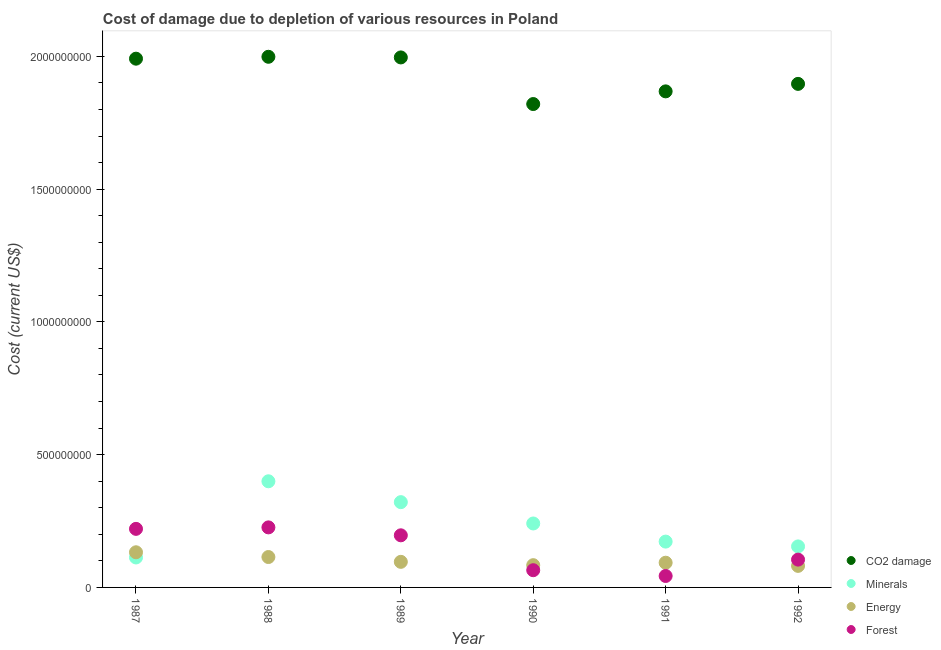Is the number of dotlines equal to the number of legend labels?
Ensure brevity in your answer.  Yes. What is the cost of damage due to depletion of energy in 1989?
Give a very brief answer. 9.63e+07. Across all years, what is the maximum cost of damage due to depletion of coal?
Your answer should be very brief. 2.00e+09. Across all years, what is the minimum cost of damage due to depletion of forests?
Offer a terse response. 4.31e+07. In which year was the cost of damage due to depletion of forests maximum?
Offer a very short reply. 1988. What is the total cost of damage due to depletion of coal in the graph?
Your answer should be very brief. 1.16e+1. What is the difference between the cost of damage due to depletion of energy in 1991 and that in 1992?
Make the answer very short. 1.19e+07. What is the difference between the cost of damage due to depletion of coal in 1987 and the cost of damage due to depletion of minerals in 1988?
Give a very brief answer. 1.59e+09. What is the average cost of damage due to depletion of energy per year?
Offer a terse response. 1.00e+08. In the year 1987, what is the difference between the cost of damage due to depletion of coal and cost of damage due to depletion of minerals?
Offer a terse response. 1.88e+09. What is the ratio of the cost of damage due to depletion of coal in 1988 to that in 1990?
Your response must be concise. 1.1. Is the cost of damage due to depletion of minerals in 1987 less than that in 1988?
Your answer should be compact. Yes. Is the difference between the cost of damage due to depletion of coal in 1987 and 1990 greater than the difference between the cost of damage due to depletion of minerals in 1987 and 1990?
Offer a terse response. Yes. What is the difference between the highest and the second highest cost of damage due to depletion of coal?
Give a very brief answer. 2.41e+06. What is the difference between the highest and the lowest cost of damage due to depletion of coal?
Offer a very short reply. 1.78e+08. Is the sum of the cost of damage due to depletion of forests in 1987 and 1990 greater than the maximum cost of damage due to depletion of coal across all years?
Ensure brevity in your answer.  No. Is it the case that in every year, the sum of the cost of damage due to depletion of coal and cost of damage due to depletion of minerals is greater than the cost of damage due to depletion of energy?
Offer a very short reply. Yes. Does the cost of damage due to depletion of minerals monotonically increase over the years?
Your answer should be compact. No. Is the cost of damage due to depletion of energy strictly less than the cost of damage due to depletion of forests over the years?
Provide a short and direct response. No. How many dotlines are there?
Your answer should be compact. 4. How many years are there in the graph?
Provide a succinct answer. 6. Does the graph contain any zero values?
Ensure brevity in your answer.  No. Where does the legend appear in the graph?
Your response must be concise. Bottom right. How many legend labels are there?
Your response must be concise. 4. What is the title of the graph?
Your answer should be very brief. Cost of damage due to depletion of various resources in Poland . Does "Public sector management" appear as one of the legend labels in the graph?
Your response must be concise. No. What is the label or title of the X-axis?
Make the answer very short. Year. What is the label or title of the Y-axis?
Offer a very short reply. Cost (current US$). What is the Cost (current US$) in CO2 damage in 1987?
Ensure brevity in your answer.  1.99e+09. What is the Cost (current US$) of Minerals in 1987?
Ensure brevity in your answer.  1.13e+08. What is the Cost (current US$) of Energy in 1987?
Provide a short and direct response. 1.32e+08. What is the Cost (current US$) in Forest in 1987?
Offer a very short reply. 2.21e+08. What is the Cost (current US$) of CO2 damage in 1988?
Offer a very short reply. 2.00e+09. What is the Cost (current US$) in Minerals in 1988?
Make the answer very short. 4.00e+08. What is the Cost (current US$) in Energy in 1988?
Keep it short and to the point. 1.14e+08. What is the Cost (current US$) of Forest in 1988?
Provide a succinct answer. 2.26e+08. What is the Cost (current US$) in CO2 damage in 1989?
Offer a very short reply. 2.00e+09. What is the Cost (current US$) of Minerals in 1989?
Your answer should be compact. 3.21e+08. What is the Cost (current US$) of Energy in 1989?
Provide a short and direct response. 9.63e+07. What is the Cost (current US$) in Forest in 1989?
Ensure brevity in your answer.  1.96e+08. What is the Cost (current US$) of CO2 damage in 1990?
Make the answer very short. 1.82e+09. What is the Cost (current US$) of Minerals in 1990?
Offer a very short reply. 2.41e+08. What is the Cost (current US$) of Energy in 1990?
Your response must be concise. 8.38e+07. What is the Cost (current US$) in Forest in 1990?
Offer a very short reply. 6.49e+07. What is the Cost (current US$) in CO2 damage in 1991?
Provide a short and direct response. 1.87e+09. What is the Cost (current US$) of Minerals in 1991?
Ensure brevity in your answer.  1.73e+08. What is the Cost (current US$) in Energy in 1991?
Provide a succinct answer. 9.31e+07. What is the Cost (current US$) in Forest in 1991?
Your answer should be compact. 4.31e+07. What is the Cost (current US$) in CO2 damage in 1992?
Your response must be concise. 1.90e+09. What is the Cost (current US$) of Minerals in 1992?
Offer a terse response. 1.54e+08. What is the Cost (current US$) of Energy in 1992?
Make the answer very short. 8.11e+07. What is the Cost (current US$) of Forest in 1992?
Provide a succinct answer. 1.05e+08. Across all years, what is the maximum Cost (current US$) of CO2 damage?
Ensure brevity in your answer.  2.00e+09. Across all years, what is the maximum Cost (current US$) of Minerals?
Your answer should be compact. 4.00e+08. Across all years, what is the maximum Cost (current US$) in Energy?
Provide a short and direct response. 1.32e+08. Across all years, what is the maximum Cost (current US$) in Forest?
Offer a very short reply. 2.26e+08. Across all years, what is the minimum Cost (current US$) in CO2 damage?
Offer a terse response. 1.82e+09. Across all years, what is the minimum Cost (current US$) of Minerals?
Keep it short and to the point. 1.13e+08. Across all years, what is the minimum Cost (current US$) of Energy?
Keep it short and to the point. 8.11e+07. Across all years, what is the minimum Cost (current US$) of Forest?
Give a very brief answer. 4.31e+07. What is the total Cost (current US$) in CO2 damage in the graph?
Your answer should be compact. 1.16e+1. What is the total Cost (current US$) in Minerals in the graph?
Make the answer very short. 1.40e+09. What is the total Cost (current US$) of Energy in the graph?
Offer a very short reply. 6.01e+08. What is the total Cost (current US$) of Forest in the graph?
Ensure brevity in your answer.  8.56e+08. What is the difference between the Cost (current US$) of CO2 damage in 1987 and that in 1988?
Provide a succinct answer. -7.11e+06. What is the difference between the Cost (current US$) of Minerals in 1987 and that in 1988?
Offer a very short reply. -2.87e+08. What is the difference between the Cost (current US$) of Energy in 1987 and that in 1988?
Your answer should be very brief. 1.79e+07. What is the difference between the Cost (current US$) of Forest in 1987 and that in 1988?
Give a very brief answer. -5.56e+06. What is the difference between the Cost (current US$) in CO2 damage in 1987 and that in 1989?
Your answer should be compact. -4.69e+06. What is the difference between the Cost (current US$) of Minerals in 1987 and that in 1989?
Keep it short and to the point. -2.08e+08. What is the difference between the Cost (current US$) of Energy in 1987 and that in 1989?
Ensure brevity in your answer.  3.60e+07. What is the difference between the Cost (current US$) of Forest in 1987 and that in 1989?
Provide a short and direct response. 2.43e+07. What is the difference between the Cost (current US$) of CO2 damage in 1987 and that in 1990?
Keep it short and to the point. 1.71e+08. What is the difference between the Cost (current US$) of Minerals in 1987 and that in 1990?
Your answer should be compact. -1.28e+08. What is the difference between the Cost (current US$) of Energy in 1987 and that in 1990?
Provide a succinct answer. 4.86e+07. What is the difference between the Cost (current US$) of Forest in 1987 and that in 1990?
Ensure brevity in your answer.  1.56e+08. What is the difference between the Cost (current US$) of CO2 damage in 1987 and that in 1991?
Keep it short and to the point. 1.23e+08. What is the difference between the Cost (current US$) in Minerals in 1987 and that in 1991?
Ensure brevity in your answer.  -5.97e+07. What is the difference between the Cost (current US$) in Energy in 1987 and that in 1991?
Your answer should be very brief. 3.93e+07. What is the difference between the Cost (current US$) of Forest in 1987 and that in 1991?
Give a very brief answer. 1.77e+08. What is the difference between the Cost (current US$) of CO2 damage in 1987 and that in 1992?
Give a very brief answer. 9.49e+07. What is the difference between the Cost (current US$) in Minerals in 1987 and that in 1992?
Make the answer very short. -4.16e+07. What is the difference between the Cost (current US$) in Energy in 1987 and that in 1992?
Your answer should be very brief. 5.13e+07. What is the difference between the Cost (current US$) in Forest in 1987 and that in 1992?
Your answer should be compact. 1.16e+08. What is the difference between the Cost (current US$) of CO2 damage in 1988 and that in 1989?
Offer a very short reply. 2.41e+06. What is the difference between the Cost (current US$) in Minerals in 1988 and that in 1989?
Provide a short and direct response. 7.86e+07. What is the difference between the Cost (current US$) in Energy in 1988 and that in 1989?
Your response must be concise. 1.81e+07. What is the difference between the Cost (current US$) in Forest in 1988 and that in 1989?
Ensure brevity in your answer.  2.99e+07. What is the difference between the Cost (current US$) of CO2 damage in 1988 and that in 1990?
Provide a short and direct response. 1.78e+08. What is the difference between the Cost (current US$) of Minerals in 1988 and that in 1990?
Offer a terse response. 1.59e+08. What is the difference between the Cost (current US$) of Energy in 1988 and that in 1990?
Provide a short and direct response. 3.07e+07. What is the difference between the Cost (current US$) in Forest in 1988 and that in 1990?
Make the answer very short. 1.61e+08. What is the difference between the Cost (current US$) in CO2 damage in 1988 and that in 1991?
Provide a succinct answer. 1.30e+08. What is the difference between the Cost (current US$) of Minerals in 1988 and that in 1991?
Your answer should be very brief. 2.27e+08. What is the difference between the Cost (current US$) in Energy in 1988 and that in 1991?
Provide a succinct answer. 2.14e+07. What is the difference between the Cost (current US$) in Forest in 1988 and that in 1991?
Provide a succinct answer. 1.83e+08. What is the difference between the Cost (current US$) of CO2 damage in 1988 and that in 1992?
Keep it short and to the point. 1.02e+08. What is the difference between the Cost (current US$) of Minerals in 1988 and that in 1992?
Make the answer very short. 2.45e+08. What is the difference between the Cost (current US$) of Energy in 1988 and that in 1992?
Keep it short and to the point. 3.34e+07. What is the difference between the Cost (current US$) in Forest in 1988 and that in 1992?
Your response must be concise. 1.21e+08. What is the difference between the Cost (current US$) in CO2 damage in 1989 and that in 1990?
Your answer should be very brief. 1.76e+08. What is the difference between the Cost (current US$) of Minerals in 1989 and that in 1990?
Ensure brevity in your answer.  8.03e+07. What is the difference between the Cost (current US$) in Energy in 1989 and that in 1990?
Give a very brief answer. 1.26e+07. What is the difference between the Cost (current US$) of Forest in 1989 and that in 1990?
Provide a succinct answer. 1.31e+08. What is the difference between the Cost (current US$) of CO2 damage in 1989 and that in 1991?
Your answer should be very brief. 1.28e+08. What is the difference between the Cost (current US$) of Minerals in 1989 and that in 1991?
Keep it short and to the point. 1.49e+08. What is the difference between the Cost (current US$) of Energy in 1989 and that in 1991?
Give a very brief answer. 3.30e+06. What is the difference between the Cost (current US$) in Forest in 1989 and that in 1991?
Keep it short and to the point. 1.53e+08. What is the difference between the Cost (current US$) in CO2 damage in 1989 and that in 1992?
Your answer should be compact. 9.96e+07. What is the difference between the Cost (current US$) of Minerals in 1989 and that in 1992?
Your answer should be compact. 1.67e+08. What is the difference between the Cost (current US$) of Energy in 1989 and that in 1992?
Provide a succinct answer. 1.52e+07. What is the difference between the Cost (current US$) of Forest in 1989 and that in 1992?
Give a very brief answer. 9.15e+07. What is the difference between the Cost (current US$) in CO2 damage in 1990 and that in 1991?
Your response must be concise. -4.77e+07. What is the difference between the Cost (current US$) of Minerals in 1990 and that in 1991?
Your answer should be very brief. 6.83e+07. What is the difference between the Cost (current US$) in Energy in 1990 and that in 1991?
Provide a short and direct response. -9.26e+06. What is the difference between the Cost (current US$) in Forest in 1990 and that in 1991?
Offer a terse response. 2.17e+07. What is the difference between the Cost (current US$) in CO2 damage in 1990 and that in 1992?
Offer a terse response. -7.59e+07. What is the difference between the Cost (current US$) of Minerals in 1990 and that in 1992?
Offer a terse response. 8.64e+07. What is the difference between the Cost (current US$) of Energy in 1990 and that in 1992?
Make the answer very short. 2.67e+06. What is the difference between the Cost (current US$) of Forest in 1990 and that in 1992?
Your answer should be compact. -3.99e+07. What is the difference between the Cost (current US$) of CO2 damage in 1991 and that in 1992?
Make the answer very short. -2.82e+07. What is the difference between the Cost (current US$) of Minerals in 1991 and that in 1992?
Provide a short and direct response. 1.81e+07. What is the difference between the Cost (current US$) of Energy in 1991 and that in 1992?
Keep it short and to the point. 1.19e+07. What is the difference between the Cost (current US$) in Forest in 1991 and that in 1992?
Your response must be concise. -6.16e+07. What is the difference between the Cost (current US$) in CO2 damage in 1987 and the Cost (current US$) in Minerals in 1988?
Your response must be concise. 1.59e+09. What is the difference between the Cost (current US$) in CO2 damage in 1987 and the Cost (current US$) in Energy in 1988?
Give a very brief answer. 1.88e+09. What is the difference between the Cost (current US$) of CO2 damage in 1987 and the Cost (current US$) of Forest in 1988?
Provide a succinct answer. 1.77e+09. What is the difference between the Cost (current US$) of Minerals in 1987 and the Cost (current US$) of Energy in 1988?
Your response must be concise. -1.66e+06. What is the difference between the Cost (current US$) in Minerals in 1987 and the Cost (current US$) in Forest in 1988?
Make the answer very short. -1.13e+08. What is the difference between the Cost (current US$) of Energy in 1987 and the Cost (current US$) of Forest in 1988?
Your response must be concise. -9.37e+07. What is the difference between the Cost (current US$) in CO2 damage in 1987 and the Cost (current US$) in Minerals in 1989?
Offer a very short reply. 1.67e+09. What is the difference between the Cost (current US$) in CO2 damage in 1987 and the Cost (current US$) in Energy in 1989?
Your response must be concise. 1.89e+09. What is the difference between the Cost (current US$) of CO2 damage in 1987 and the Cost (current US$) of Forest in 1989?
Provide a short and direct response. 1.80e+09. What is the difference between the Cost (current US$) of Minerals in 1987 and the Cost (current US$) of Energy in 1989?
Your answer should be compact. 1.65e+07. What is the difference between the Cost (current US$) in Minerals in 1987 and the Cost (current US$) in Forest in 1989?
Give a very brief answer. -8.34e+07. What is the difference between the Cost (current US$) of Energy in 1987 and the Cost (current US$) of Forest in 1989?
Your answer should be compact. -6.39e+07. What is the difference between the Cost (current US$) of CO2 damage in 1987 and the Cost (current US$) of Minerals in 1990?
Keep it short and to the point. 1.75e+09. What is the difference between the Cost (current US$) of CO2 damage in 1987 and the Cost (current US$) of Energy in 1990?
Provide a short and direct response. 1.91e+09. What is the difference between the Cost (current US$) in CO2 damage in 1987 and the Cost (current US$) in Forest in 1990?
Ensure brevity in your answer.  1.93e+09. What is the difference between the Cost (current US$) in Minerals in 1987 and the Cost (current US$) in Energy in 1990?
Provide a succinct answer. 2.90e+07. What is the difference between the Cost (current US$) of Minerals in 1987 and the Cost (current US$) of Forest in 1990?
Provide a succinct answer. 4.80e+07. What is the difference between the Cost (current US$) in Energy in 1987 and the Cost (current US$) in Forest in 1990?
Your response must be concise. 6.75e+07. What is the difference between the Cost (current US$) in CO2 damage in 1987 and the Cost (current US$) in Minerals in 1991?
Provide a succinct answer. 1.82e+09. What is the difference between the Cost (current US$) in CO2 damage in 1987 and the Cost (current US$) in Energy in 1991?
Provide a short and direct response. 1.90e+09. What is the difference between the Cost (current US$) of CO2 damage in 1987 and the Cost (current US$) of Forest in 1991?
Make the answer very short. 1.95e+09. What is the difference between the Cost (current US$) in Minerals in 1987 and the Cost (current US$) in Energy in 1991?
Provide a short and direct response. 1.98e+07. What is the difference between the Cost (current US$) in Minerals in 1987 and the Cost (current US$) in Forest in 1991?
Keep it short and to the point. 6.97e+07. What is the difference between the Cost (current US$) in Energy in 1987 and the Cost (current US$) in Forest in 1991?
Keep it short and to the point. 8.93e+07. What is the difference between the Cost (current US$) of CO2 damage in 1987 and the Cost (current US$) of Minerals in 1992?
Keep it short and to the point. 1.84e+09. What is the difference between the Cost (current US$) of CO2 damage in 1987 and the Cost (current US$) of Energy in 1992?
Give a very brief answer. 1.91e+09. What is the difference between the Cost (current US$) in CO2 damage in 1987 and the Cost (current US$) in Forest in 1992?
Give a very brief answer. 1.89e+09. What is the difference between the Cost (current US$) of Minerals in 1987 and the Cost (current US$) of Energy in 1992?
Your answer should be compact. 3.17e+07. What is the difference between the Cost (current US$) in Minerals in 1987 and the Cost (current US$) in Forest in 1992?
Your answer should be very brief. 8.09e+06. What is the difference between the Cost (current US$) of Energy in 1987 and the Cost (current US$) of Forest in 1992?
Provide a short and direct response. 2.76e+07. What is the difference between the Cost (current US$) in CO2 damage in 1988 and the Cost (current US$) in Minerals in 1989?
Give a very brief answer. 1.68e+09. What is the difference between the Cost (current US$) in CO2 damage in 1988 and the Cost (current US$) in Energy in 1989?
Ensure brevity in your answer.  1.90e+09. What is the difference between the Cost (current US$) of CO2 damage in 1988 and the Cost (current US$) of Forest in 1989?
Keep it short and to the point. 1.80e+09. What is the difference between the Cost (current US$) in Minerals in 1988 and the Cost (current US$) in Energy in 1989?
Your response must be concise. 3.03e+08. What is the difference between the Cost (current US$) in Minerals in 1988 and the Cost (current US$) in Forest in 1989?
Your answer should be compact. 2.03e+08. What is the difference between the Cost (current US$) in Energy in 1988 and the Cost (current US$) in Forest in 1989?
Provide a succinct answer. -8.18e+07. What is the difference between the Cost (current US$) of CO2 damage in 1988 and the Cost (current US$) of Minerals in 1990?
Provide a succinct answer. 1.76e+09. What is the difference between the Cost (current US$) in CO2 damage in 1988 and the Cost (current US$) in Energy in 1990?
Provide a succinct answer. 1.91e+09. What is the difference between the Cost (current US$) in CO2 damage in 1988 and the Cost (current US$) in Forest in 1990?
Your answer should be very brief. 1.93e+09. What is the difference between the Cost (current US$) of Minerals in 1988 and the Cost (current US$) of Energy in 1990?
Ensure brevity in your answer.  3.16e+08. What is the difference between the Cost (current US$) of Minerals in 1988 and the Cost (current US$) of Forest in 1990?
Your answer should be very brief. 3.35e+08. What is the difference between the Cost (current US$) of Energy in 1988 and the Cost (current US$) of Forest in 1990?
Give a very brief answer. 4.96e+07. What is the difference between the Cost (current US$) of CO2 damage in 1988 and the Cost (current US$) of Minerals in 1991?
Ensure brevity in your answer.  1.83e+09. What is the difference between the Cost (current US$) of CO2 damage in 1988 and the Cost (current US$) of Energy in 1991?
Give a very brief answer. 1.91e+09. What is the difference between the Cost (current US$) of CO2 damage in 1988 and the Cost (current US$) of Forest in 1991?
Offer a terse response. 1.96e+09. What is the difference between the Cost (current US$) in Minerals in 1988 and the Cost (current US$) in Energy in 1991?
Your answer should be compact. 3.07e+08. What is the difference between the Cost (current US$) of Minerals in 1988 and the Cost (current US$) of Forest in 1991?
Make the answer very short. 3.57e+08. What is the difference between the Cost (current US$) of Energy in 1988 and the Cost (current US$) of Forest in 1991?
Provide a short and direct response. 7.14e+07. What is the difference between the Cost (current US$) in CO2 damage in 1988 and the Cost (current US$) in Minerals in 1992?
Keep it short and to the point. 1.84e+09. What is the difference between the Cost (current US$) in CO2 damage in 1988 and the Cost (current US$) in Energy in 1992?
Provide a succinct answer. 1.92e+09. What is the difference between the Cost (current US$) of CO2 damage in 1988 and the Cost (current US$) of Forest in 1992?
Your answer should be compact. 1.89e+09. What is the difference between the Cost (current US$) of Minerals in 1988 and the Cost (current US$) of Energy in 1992?
Keep it short and to the point. 3.19e+08. What is the difference between the Cost (current US$) in Minerals in 1988 and the Cost (current US$) in Forest in 1992?
Keep it short and to the point. 2.95e+08. What is the difference between the Cost (current US$) of Energy in 1988 and the Cost (current US$) of Forest in 1992?
Your answer should be very brief. 9.74e+06. What is the difference between the Cost (current US$) in CO2 damage in 1989 and the Cost (current US$) in Minerals in 1990?
Offer a terse response. 1.76e+09. What is the difference between the Cost (current US$) of CO2 damage in 1989 and the Cost (current US$) of Energy in 1990?
Provide a succinct answer. 1.91e+09. What is the difference between the Cost (current US$) of CO2 damage in 1989 and the Cost (current US$) of Forest in 1990?
Keep it short and to the point. 1.93e+09. What is the difference between the Cost (current US$) of Minerals in 1989 and the Cost (current US$) of Energy in 1990?
Make the answer very short. 2.37e+08. What is the difference between the Cost (current US$) in Minerals in 1989 and the Cost (current US$) in Forest in 1990?
Provide a short and direct response. 2.56e+08. What is the difference between the Cost (current US$) of Energy in 1989 and the Cost (current US$) of Forest in 1990?
Ensure brevity in your answer.  3.15e+07. What is the difference between the Cost (current US$) of CO2 damage in 1989 and the Cost (current US$) of Minerals in 1991?
Offer a very short reply. 1.82e+09. What is the difference between the Cost (current US$) in CO2 damage in 1989 and the Cost (current US$) in Energy in 1991?
Give a very brief answer. 1.90e+09. What is the difference between the Cost (current US$) of CO2 damage in 1989 and the Cost (current US$) of Forest in 1991?
Offer a terse response. 1.95e+09. What is the difference between the Cost (current US$) in Minerals in 1989 and the Cost (current US$) in Energy in 1991?
Your response must be concise. 2.28e+08. What is the difference between the Cost (current US$) in Minerals in 1989 and the Cost (current US$) in Forest in 1991?
Keep it short and to the point. 2.78e+08. What is the difference between the Cost (current US$) of Energy in 1989 and the Cost (current US$) of Forest in 1991?
Provide a short and direct response. 5.32e+07. What is the difference between the Cost (current US$) in CO2 damage in 1989 and the Cost (current US$) in Minerals in 1992?
Your response must be concise. 1.84e+09. What is the difference between the Cost (current US$) in CO2 damage in 1989 and the Cost (current US$) in Energy in 1992?
Provide a short and direct response. 1.91e+09. What is the difference between the Cost (current US$) of CO2 damage in 1989 and the Cost (current US$) of Forest in 1992?
Offer a very short reply. 1.89e+09. What is the difference between the Cost (current US$) of Minerals in 1989 and the Cost (current US$) of Energy in 1992?
Keep it short and to the point. 2.40e+08. What is the difference between the Cost (current US$) of Minerals in 1989 and the Cost (current US$) of Forest in 1992?
Your response must be concise. 2.16e+08. What is the difference between the Cost (current US$) in Energy in 1989 and the Cost (current US$) in Forest in 1992?
Your response must be concise. -8.39e+06. What is the difference between the Cost (current US$) of CO2 damage in 1990 and the Cost (current US$) of Minerals in 1991?
Provide a succinct answer. 1.65e+09. What is the difference between the Cost (current US$) in CO2 damage in 1990 and the Cost (current US$) in Energy in 1991?
Your answer should be compact. 1.73e+09. What is the difference between the Cost (current US$) in CO2 damage in 1990 and the Cost (current US$) in Forest in 1991?
Your answer should be very brief. 1.78e+09. What is the difference between the Cost (current US$) in Minerals in 1990 and the Cost (current US$) in Energy in 1991?
Offer a very short reply. 1.48e+08. What is the difference between the Cost (current US$) of Minerals in 1990 and the Cost (current US$) of Forest in 1991?
Offer a terse response. 1.98e+08. What is the difference between the Cost (current US$) of Energy in 1990 and the Cost (current US$) of Forest in 1991?
Keep it short and to the point. 4.07e+07. What is the difference between the Cost (current US$) of CO2 damage in 1990 and the Cost (current US$) of Minerals in 1992?
Give a very brief answer. 1.67e+09. What is the difference between the Cost (current US$) of CO2 damage in 1990 and the Cost (current US$) of Energy in 1992?
Give a very brief answer. 1.74e+09. What is the difference between the Cost (current US$) of CO2 damage in 1990 and the Cost (current US$) of Forest in 1992?
Offer a very short reply. 1.72e+09. What is the difference between the Cost (current US$) in Minerals in 1990 and the Cost (current US$) in Energy in 1992?
Provide a succinct answer. 1.60e+08. What is the difference between the Cost (current US$) in Minerals in 1990 and the Cost (current US$) in Forest in 1992?
Ensure brevity in your answer.  1.36e+08. What is the difference between the Cost (current US$) in Energy in 1990 and the Cost (current US$) in Forest in 1992?
Your answer should be very brief. -2.09e+07. What is the difference between the Cost (current US$) in CO2 damage in 1991 and the Cost (current US$) in Minerals in 1992?
Provide a short and direct response. 1.71e+09. What is the difference between the Cost (current US$) of CO2 damage in 1991 and the Cost (current US$) of Energy in 1992?
Your response must be concise. 1.79e+09. What is the difference between the Cost (current US$) in CO2 damage in 1991 and the Cost (current US$) in Forest in 1992?
Ensure brevity in your answer.  1.76e+09. What is the difference between the Cost (current US$) in Minerals in 1991 and the Cost (current US$) in Energy in 1992?
Provide a succinct answer. 9.14e+07. What is the difference between the Cost (current US$) in Minerals in 1991 and the Cost (current US$) in Forest in 1992?
Provide a short and direct response. 6.78e+07. What is the difference between the Cost (current US$) in Energy in 1991 and the Cost (current US$) in Forest in 1992?
Offer a terse response. -1.17e+07. What is the average Cost (current US$) in CO2 damage per year?
Your answer should be very brief. 1.93e+09. What is the average Cost (current US$) in Minerals per year?
Ensure brevity in your answer.  2.34e+08. What is the average Cost (current US$) in Energy per year?
Offer a very short reply. 1.00e+08. What is the average Cost (current US$) of Forest per year?
Give a very brief answer. 1.43e+08. In the year 1987, what is the difference between the Cost (current US$) of CO2 damage and Cost (current US$) of Minerals?
Offer a very short reply. 1.88e+09. In the year 1987, what is the difference between the Cost (current US$) in CO2 damage and Cost (current US$) in Energy?
Offer a very short reply. 1.86e+09. In the year 1987, what is the difference between the Cost (current US$) of CO2 damage and Cost (current US$) of Forest?
Your answer should be compact. 1.77e+09. In the year 1987, what is the difference between the Cost (current US$) of Minerals and Cost (current US$) of Energy?
Your answer should be very brief. -1.96e+07. In the year 1987, what is the difference between the Cost (current US$) of Minerals and Cost (current US$) of Forest?
Your answer should be very brief. -1.08e+08. In the year 1987, what is the difference between the Cost (current US$) in Energy and Cost (current US$) in Forest?
Your answer should be very brief. -8.82e+07. In the year 1988, what is the difference between the Cost (current US$) of CO2 damage and Cost (current US$) of Minerals?
Offer a very short reply. 1.60e+09. In the year 1988, what is the difference between the Cost (current US$) in CO2 damage and Cost (current US$) in Energy?
Keep it short and to the point. 1.88e+09. In the year 1988, what is the difference between the Cost (current US$) of CO2 damage and Cost (current US$) of Forest?
Provide a short and direct response. 1.77e+09. In the year 1988, what is the difference between the Cost (current US$) of Minerals and Cost (current US$) of Energy?
Your answer should be very brief. 2.85e+08. In the year 1988, what is the difference between the Cost (current US$) in Minerals and Cost (current US$) in Forest?
Keep it short and to the point. 1.74e+08. In the year 1988, what is the difference between the Cost (current US$) in Energy and Cost (current US$) in Forest?
Offer a very short reply. -1.12e+08. In the year 1989, what is the difference between the Cost (current US$) of CO2 damage and Cost (current US$) of Minerals?
Offer a terse response. 1.67e+09. In the year 1989, what is the difference between the Cost (current US$) of CO2 damage and Cost (current US$) of Energy?
Ensure brevity in your answer.  1.90e+09. In the year 1989, what is the difference between the Cost (current US$) in CO2 damage and Cost (current US$) in Forest?
Offer a terse response. 1.80e+09. In the year 1989, what is the difference between the Cost (current US$) of Minerals and Cost (current US$) of Energy?
Your answer should be very brief. 2.25e+08. In the year 1989, what is the difference between the Cost (current US$) in Minerals and Cost (current US$) in Forest?
Provide a succinct answer. 1.25e+08. In the year 1989, what is the difference between the Cost (current US$) in Energy and Cost (current US$) in Forest?
Your response must be concise. -9.99e+07. In the year 1990, what is the difference between the Cost (current US$) in CO2 damage and Cost (current US$) in Minerals?
Provide a short and direct response. 1.58e+09. In the year 1990, what is the difference between the Cost (current US$) of CO2 damage and Cost (current US$) of Energy?
Your answer should be compact. 1.74e+09. In the year 1990, what is the difference between the Cost (current US$) of CO2 damage and Cost (current US$) of Forest?
Offer a terse response. 1.76e+09. In the year 1990, what is the difference between the Cost (current US$) of Minerals and Cost (current US$) of Energy?
Ensure brevity in your answer.  1.57e+08. In the year 1990, what is the difference between the Cost (current US$) in Minerals and Cost (current US$) in Forest?
Your answer should be compact. 1.76e+08. In the year 1990, what is the difference between the Cost (current US$) in Energy and Cost (current US$) in Forest?
Offer a very short reply. 1.89e+07. In the year 1991, what is the difference between the Cost (current US$) in CO2 damage and Cost (current US$) in Minerals?
Your answer should be very brief. 1.70e+09. In the year 1991, what is the difference between the Cost (current US$) of CO2 damage and Cost (current US$) of Energy?
Keep it short and to the point. 1.78e+09. In the year 1991, what is the difference between the Cost (current US$) of CO2 damage and Cost (current US$) of Forest?
Provide a short and direct response. 1.83e+09. In the year 1991, what is the difference between the Cost (current US$) in Minerals and Cost (current US$) in Energy?
Your response must be concise. 7.95e+07. In the year 1991, what is the difference between the Cost (current US$) in Minerals and Cost (current US$) in Forest?
Provide a succinct answer. 1.29e+08. In the year 1991, what is the difference between the Cost (current US$) in Energy and Cost (current US$) in Forest?
Offer a very short reply. 4.99e+07. In the year 1992, what is the difference between the Cost (current US$) in CO2 damage and Cost (current US$) in Minerals?
Make the answer very short. 1.74e+09. In the year 1992, what is the difference between the Cost (current US$) in CO2 damage and Cost (current US$) in Energy?
Provide a short and direct response. 1.82e+09. In the year 1992, what is the difference between the Cost (current US$) in CO2 damage and Cost (current US$) in Forest?
Your response must be concise. 1.79e+09. In the year 1992, what is the difference between the Cost (current US$) of Minerals and Cost (current US$) of Energy?
Make the answer very short. 7.33e+07. In the year 1992, what is the difference between the Cost (current US$) of Minerals and Cost (current US$) of Forest?
Provide a short and direct response. 4.97e+07. In the year 1992, what is the difference between the Cost (current US$) of Energy and Cost (current US$) of Forest?
Give a very brief answer. -2.36e+07. What is the ratio of the Cost (current US$) of CO2 damage in 1987 to that in 1988?
Your answer should be compact. 1. What is the ratio of the Cost (current US$) of Minerals in 1987 to that in 1988?
Provide a succinct answer. 0.28. What is the ratio of the Cost (current US$) of Energy in 1987 to that in 1988?
Offer a very short reply. 1.16. What is the ratio of the Cost (current US$) of Forest in 1987 to that in 1988?
Your answer should be very brief. 0.98. What is the ratio of the Cost (current US$) of CO2 damage in 1987 to that in 1989?
Offer a very short reply. 1. What is the ratio of the Cost (current US$) in Minerals in 1987 to that in 1989?
Ensure brevity in your answer.  0.35. What is the ratio of the Cost (current US$) of Energy in 1987 to that in 1989?
Your response must be concise. 1.37. What is the ratio of the Cost (current US$) in Forest in 1987 to that in 1989?
Give a very brief answer. 1.12. What is the ratio of the Cost (current US$) in CO2 damage in 1987 to that in 1990?
Your answer should be compact. 1.09. What is the ratio of the Cost (current US$) in Minerals in 1987 to that in 1990?
Keep it short and to the point. 0.47. What is the ratio of the Cost (current US$) of Energy in 1987 to that in 1990?
Make the answer very short. 1.58. What is the ratio of the Cost (current US$) of Forest in 1987 to that in 1990?
Give a very brief answer. 3.4. What is the ratio of the Cost (current US$) in CO2 damage in 1987 to that in 1991?
Ensure brevity in your answer.  1.07. What is the ratio of the Cost (current US$) of Minerals in 1987 to that in 1991?
Ensure brevity in your answer.  0.65. What is the ratio of the Cost (current US$) in Energy in 1987 to that in 1991?
Give a very brief answer. 1.42. What is the ratio of the Cost (current US$) of Forest in 1987 to that in 1991?
Provide a succinct answer. 5.12. What is the ratio of the Cost (current US$) in CO2 damage in 1987 to that in 1992?
Your answer should be very brief. 1.05. What is the ratio of the Cost (current US$) of Minerals in 1987 to that in 1992?
Make the answer very short. 0.73. What is the ratio of the Cost (current US$) of Energy in 1987 to that in 1992?
Keep it short and to the point. 1.63. What is the ratio of the Cost (current US$) of Forest in 1987 to that in 1992?
Offer a terse response. 2.11. What is the ratio of the Cost (current US$) of Minerals in 1988 to that in 1989?
Make the answer very short. 1.24. What is the ratio of the Cost (current US$) in Energy in 1988 to that in 1989?
Ensure brevity in your answer.  1.19. What is the ratio of the Cost (current US$) in Forest in 1988 to that in 1989?
Give a very brief answer. 1.15. What is the ratio of the Cost (current US$) in CO2 damage in 1988 to that in 1990?
Your answer should be very brief. 1.1. What is the ratio of the Cost (current US$) of Minerals in 1988 to that in 1990?
Keep it short and to the point. 1.66. What is the ratio of the Cost (current US$) of Energy in 1988 to that in 1990?
Provide a succinct answer. 1.37. What is the ratio of the Cost (current US$) in Forest in 1988 to that in 1990?
Your answer should be very brief. 3.49. What is the ratio of the Cost (current US$) in CO2 damage in 1988 to that in 1991?
Your answer should be compact. 1.07. What is the ratio of the Cost (current US$) of Minerals in 1988 to that in 1991?
Provide a short and direct response. 2.32. What is the ratio of the Cost (current US$) of Energy in 1988 to that in 1991?
Provide a succinct answer. 1.23. What is the ratio of the Cost (current US$) in Forest in 1988 to that in 1991?
Provide a succinct answer. 5.25. What is the ratio of the Cost (current US$) in CO2 damage in 1988 to that in 1992?
Offer a terse response. 1.05. What is the ratio of the Cost (current US$) in Minerals in 1988 to that in 1992?
Keep it short and to the point. 2.59. What is the ratio of the Cost (current US$) in Energy in 1988 to that in 1992?
Provide a succinct answer. 1.41. What is the ratio of the Cost (current US$) of Forest in 1988 to that in 1992?
Your response must be concise. 2.16. What is the ratio of the Cost (current US$) in CO2 damage in 1989 to that in 1990?
Offer a very short reply. 1.1. What is the ratio of the Cost (current US$) of Minerals in 1989 to that in 1990?
Provide a short and direct response. 1.33. What is the ratio of the Cost (current US$) of Energy in 1989 to that in 1990?
Ensure brevity in your answer.  1.15. What is the ratio of the Cost (current US$) of Forest in 1989 to that in 1990?
Offer a terse response. 3.03. What is the ratio of the Cost (current US$) in CO2 damage in 1989 to that in 1991?
Keep it short and to the point. 1.07. What is the ratio of the Cost (current US$) in Minerals in 1989 to that in 1991?
Offer a terse response. 1.86. What is the ratio of the Cost (current US$) of Energy in 1989 to that in 1991?
Make the answer very short. 1.04. What is the ratio of the Cost (current US$) in Forest in 1989 to that in 1991?
Your answer should be very brief. 4.55. What is the ratio of the Cost (current US$) in CO2 damage in 1989 to that in 1992?
Provide a short and direct response. 1.05. What is the ratio of the Cost (current US$) of Minerals in 1989 to that in 1992?
Your answer should be very brief. 2.08. What is the ratio of the Cost (current US$) of Energy in 1989 to that in 1992?
Your answer should be compact. 1.19. What is the ratio of the Cost (current US$) of Forest in 1989 to that in 1992?
Your response must be concise. 1.87. What is the ratio of the Cost (current US$) of CO2 damage in 1990 to that in 1991?
Offer a very short reply. 0.97. What is the ratio of the Cost (current US$) in Minerals in 1990 to that in 1991?
Your response must be concise. 1.4. What is the ratio of the Cost (current US$) in Energy in 1990 to that in 1991?
Offer a terse response. 0.9. What is the ratio of the Cost (current US$) of Forest in 1990 to that in 1991?
Make the answer very short. 1.5. What is the ratio of the Cost (current US$) of Minerals in 1990 to that in 1992?
Ensure brevity in your answer.  1.56. What is the ratio of the Cost (current US$) of Energy in 1990 to that in 1992?
Your answer should be very brief. 1.03. What is the ratio of the Cost (current US$) of Forest in 1990 to that in 1992?
Your answer should be very brief. 0.62. What is the ratio of the Cost (current US$) in CO2 damage in 1991 to that in 1992?
Offer a terse response. 0.99. What is the ratio of the Cost (current US$) of Minerals in 1991 to that in 1992?
Make the answer very short. 1.12. What is the ratio of the Cost (current US$) in Energy in 1991 to that in 1992?
Your answer should be very brief. 1.15. What is the ratio of the Cost (current US$) of Forest in 1991 to that in 1992?
Offer a very short reply. 0.41. What is the difference between the highest and the second highest Cost (current US$) of CO2 damage?
Make the answer very short. 2.41e+06. What is the difference between the highest and the second highest Cost (current US$) in Minerals?
Provide a succinct answer. 7.86e+07. What is the difference between the highest and the second highest Cost (current US$) of Energy?
Your answer should be compact. 1.79e+07. What is the difference between the highest and the second highest Cost (current US$) in Forest?
Your answer should be very brief. 5.56e+06. What is the difference between the highest and the lowest Cost (current US$) of CO2 damage?
Ensure brevity in your answer.  1.78e+08. What is the difference between the highest and the lowest Cost (current US$) of Minerals?
Provide a succinct answer. 2.87e+08. What is the difference between the highest and the lowest Cost (current US$) in Energy?
Provide a succinct answer. 5.13e+07. What is the difference between the highest and the lowest Cost (current US$) of Forest?
Make the answer very short. 1.83e+08. 